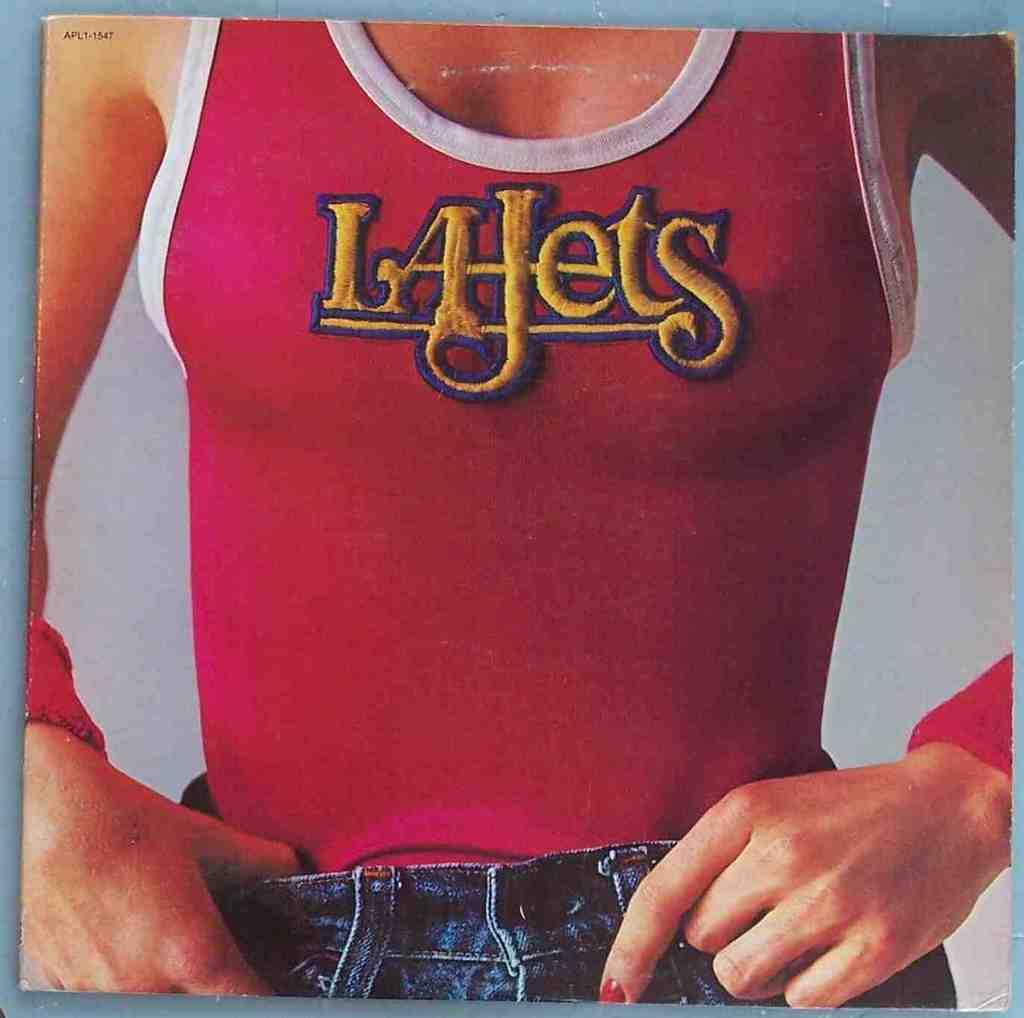Provide a one-sentence caption for the provided image. The woman is wearing a tight red La Jets tank top, and a pair of blue jeans. 